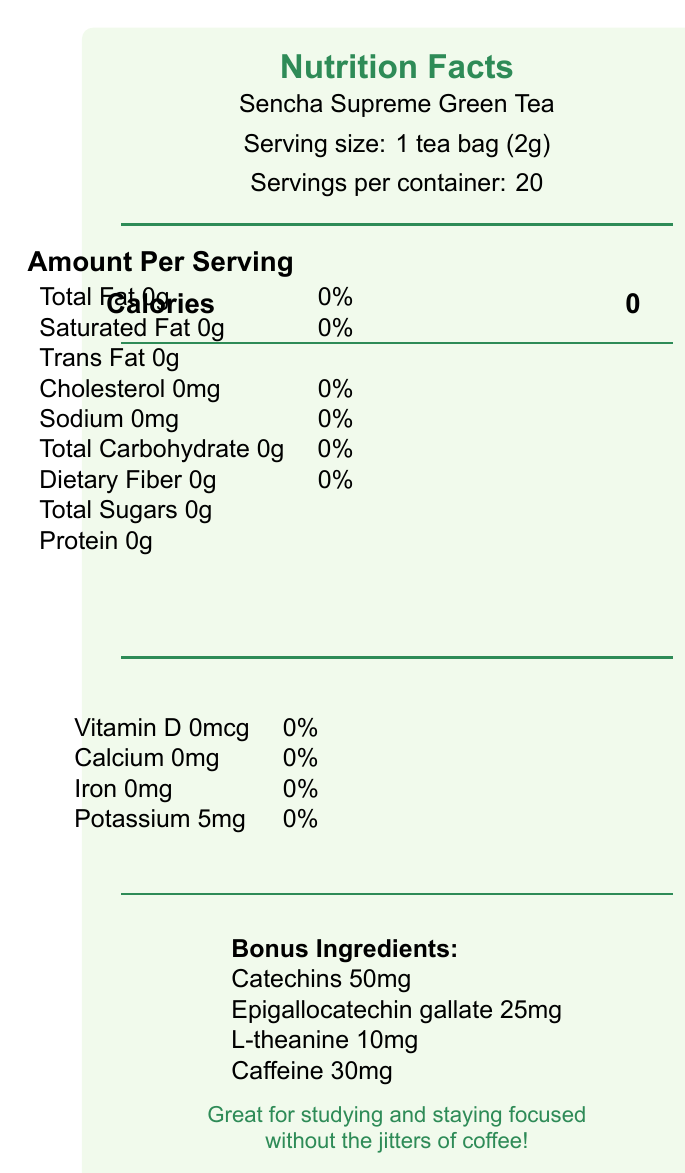what is the serving size of Sencha Supreme Green Tea? The serving size is explicitly mentioned in the document as "Serving size: 1 tea bag (2g)".
Answer: 1 tea bag (2g) how many servings are there per container? The document states there are "Servings per container: 20".
Answer: 20 how many calories are in one serving? The document lists "Calories: 0" under the "Amount Per Serving" section.
Answer: 0 calories what is the amount of caffeine per serving? The bonus ingredients section lists "Caffeine 30mg".
Answer: 30mg can studying benefit from drinking this green tea? The document states "Great for studying and staying focused without the jitters of coffee".
Answer: Yes which of the following contains antioxidants that may help boost metabolism? A. Catechins B. L-theanine C. Potassium Catechins are listed in the document and are known to have antioxidant properties, including boosting metabolism.
Answer: A. Catechins which is a suggested sushi pairing with Sencha Supreme Green Tea? A. Tuna nigiri B. Salmon sashimi C. Cucumber maki The sushi pairing suggestion mentioned is "Complements light sushi rolls like cucumber maki".
Answer: C. Cucumber maki does Sencha Supreme Green Tea contain any dietary fiber? The document lists "Dietary Fiber 0g".
Answer: No does this product contain any allergens? The allergen information notes that it is "Processed in a facility that also processes soy".
Answer: Yes summarize the nutrition facts for Sencha Supreme Green Tea. The document provides detailed nutrition facts emphasizing that the tea is calorie-free and rich in specific beneficial compounds.
Answer: Sencha Supreme Green Tea has 0 calories per serving, with no fats, cholesterol, sodium, carbohydrates, fibers, sugars, or protein. It contains 5mg of potassium per serving and includes bonus ingredients: 50mg of catechins, 25mg of epigallocatechin gallate, 10mg of l-theanine, and 30mg of caffeine. what is the shelf life of the Sencha Supreme Green Tea? The document mentions the “Best before date” but does not specify the exact shelf life.
Answer: Cannot be determined 